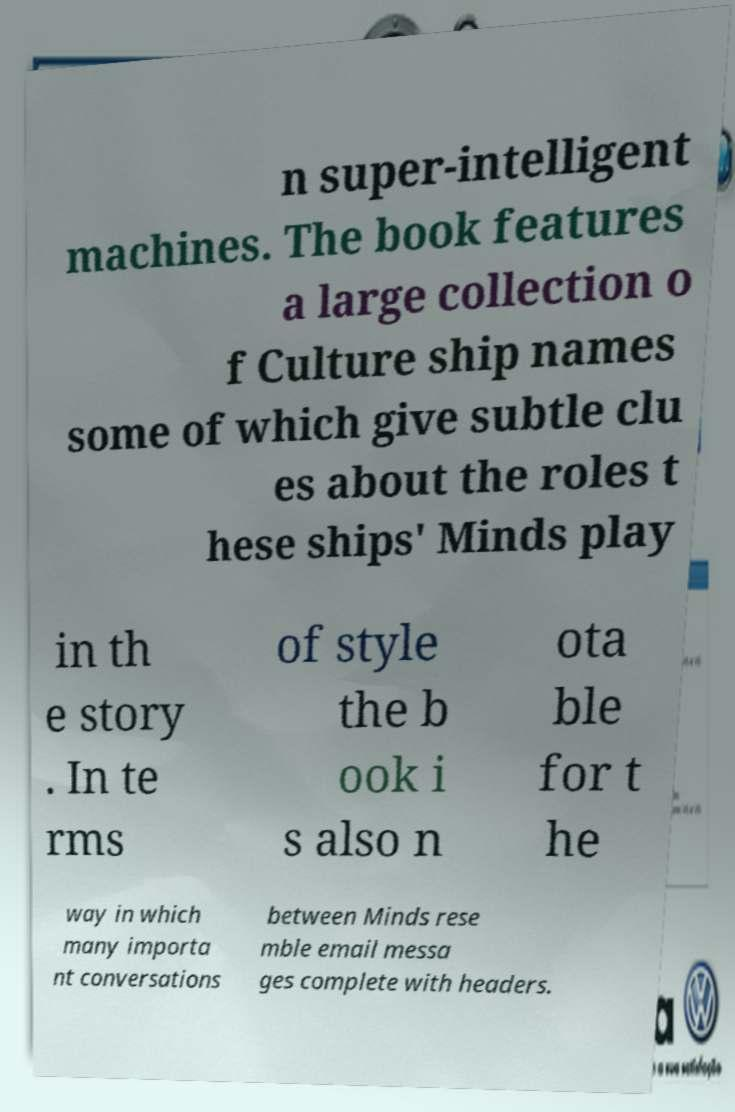Can you accurately transcribe the text from the provided image for me? n super-intelligent machines. The book features a large collection o f Culture ship names some of which give subtle clu es about the roles t hese ships' Minds play in th e story . In te rms of style the b ook i s also n ota ble for t he way in which many importa nt conversations between Minds rese mble email messa ges complete with headers. 